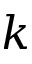<formula> <loc_0><loc_0><loc_500><loc_500>k</formula> 